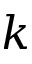<formula> <loc_0><loc_0><loc_500><loc_500>k</formula> 